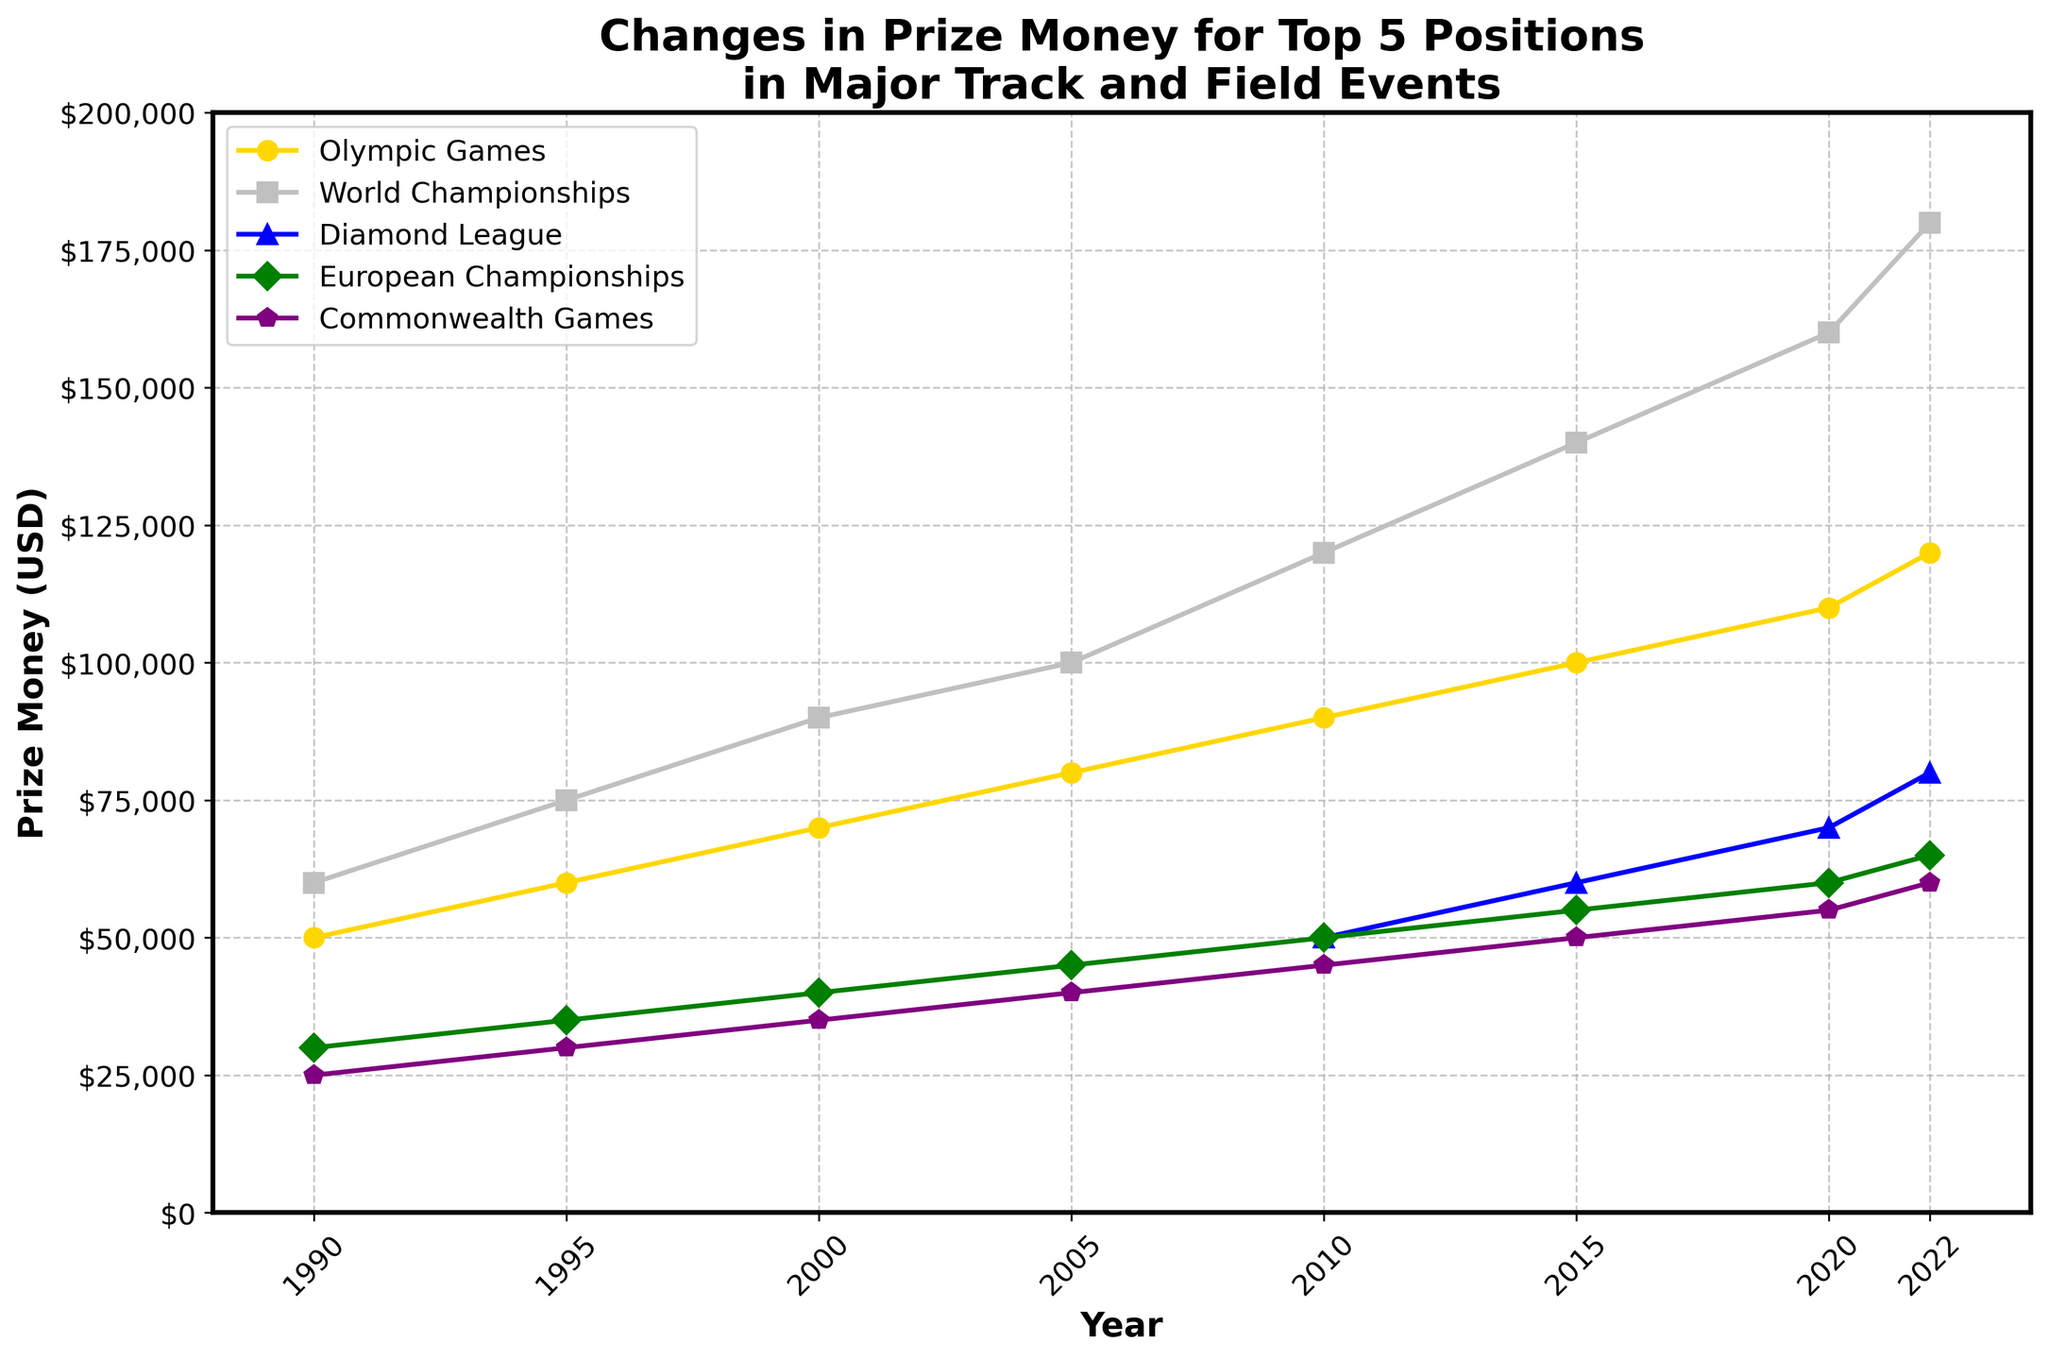What's the trend of prize money for the Olympic Games over the years? Look at the line representing the Olympic Games. It starts at $50,000 in 1990 and increases steadily to $120,000 by 2022. The trend is one of consistent growth.
Answer: Consistent growth In which year did the World Championships first exceed $100,000 in prize money? Examine the line representing the World Championships. The prize money exceeds $100,000 for the first time in 2005, reaching $100,000.
Answer: 2005 Which event had the highest prize money in 2022? Observe the lines and their final points in 2022. The World Championships had the highest prize money, at $180,000.
Answer: World Championships What is the difference in prize money between the European Championships and Commonwealth Games in the year 2005? In 2005, the European Championships' prize money was $45,000, and the Commonwealth Games' was $40,000. The difference is $45,000 - $40,000 = $5,000.
Answer: $5,000 How much did the prize money for the Diamond League change from 2010 to 2022? The Diamond League prize money was $50,000 in 2010 and increased to $80,000 by 2022. The change is $80,000 - $50,000 = $30,000.
Answer: $30,000 Between 2000 and 2022, which event saw the largest absolute increase in prize money? Calculate the increase for all events: Olympic Games ($120,000 - $70,000 = $50,000), World Championships ($180,000 - $90,000 = $90,000), Diamond League ($80,000 - $50,000 = $30,000), European Championships ($65,000 - $40,000 = $25,000), Commonwealth Games ($60,000 - $35,000 = $25,000). The World Championships had the largest increase.
Answer: World Championships In 2015, which event had the lowest prize money? Look at the plotted points for 2015. The Commonwealth Games had the lowest prize money at $50,000.
Answer: Commonwealth Games What’s the average prize money of the Olympic Games and World Championships in the year 2020? The prize money for the Olympic Games in 2020 was $110,000, and for the World Championships, it was $160,000. The average is ($110,000 + $160,000) / 2 = $135,000.
Answer: $135,000 How do the trends for the European Championships and Commonwealth Games compare from 1990 to 2022? Both events show a steady increase. The European Championships start at $30,000 in 1990 and rise to $65,000 in 2022. The Commonwealth Games start at $25,000 and rise to $60,000. Both show consistent growth, with European Championships generally higher and diverging more significantly post-2010.
Answer: Steady increase, European Championships higher Which year shows the introduction of prize money for the Diamond League? Look for the first year the Diamond League appears on the chart. Prize money for this event starts appearing in 2010 at $50,000.
Answer: 2010 